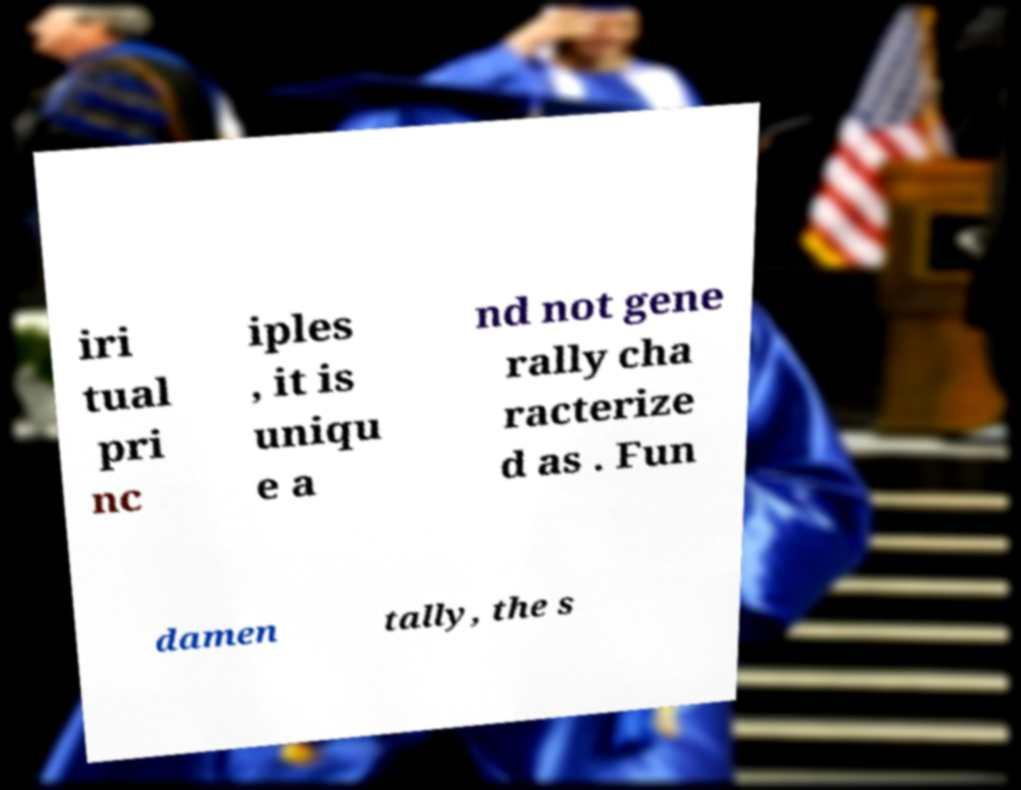Could you assist in decoding the text presented in this image and type it out clearly? iri tual pri nc iples , it is uniqu e a nd not gene rally cha racterize d as . Fun damen tally, the s 